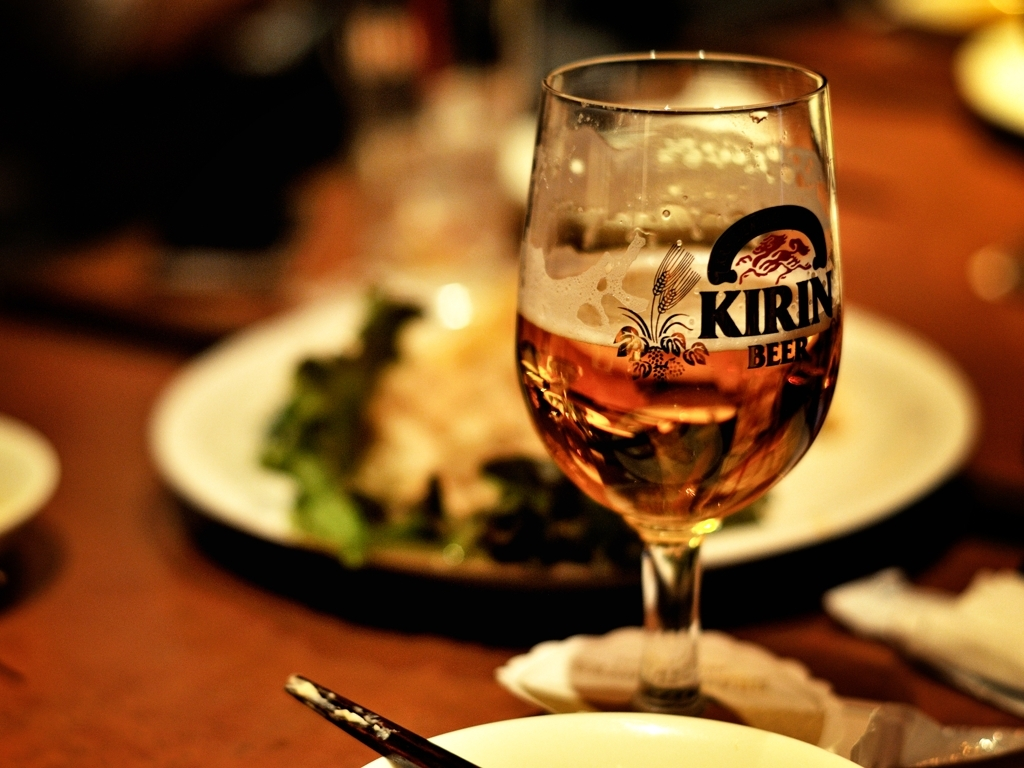Does the brand on the glass provide any cultural context? The brand visible on the glass is a beer brand known for its roots in a specific country, suggesting that this beverage is either imported or that the setting has cultural ties to the brand's country of origin. 